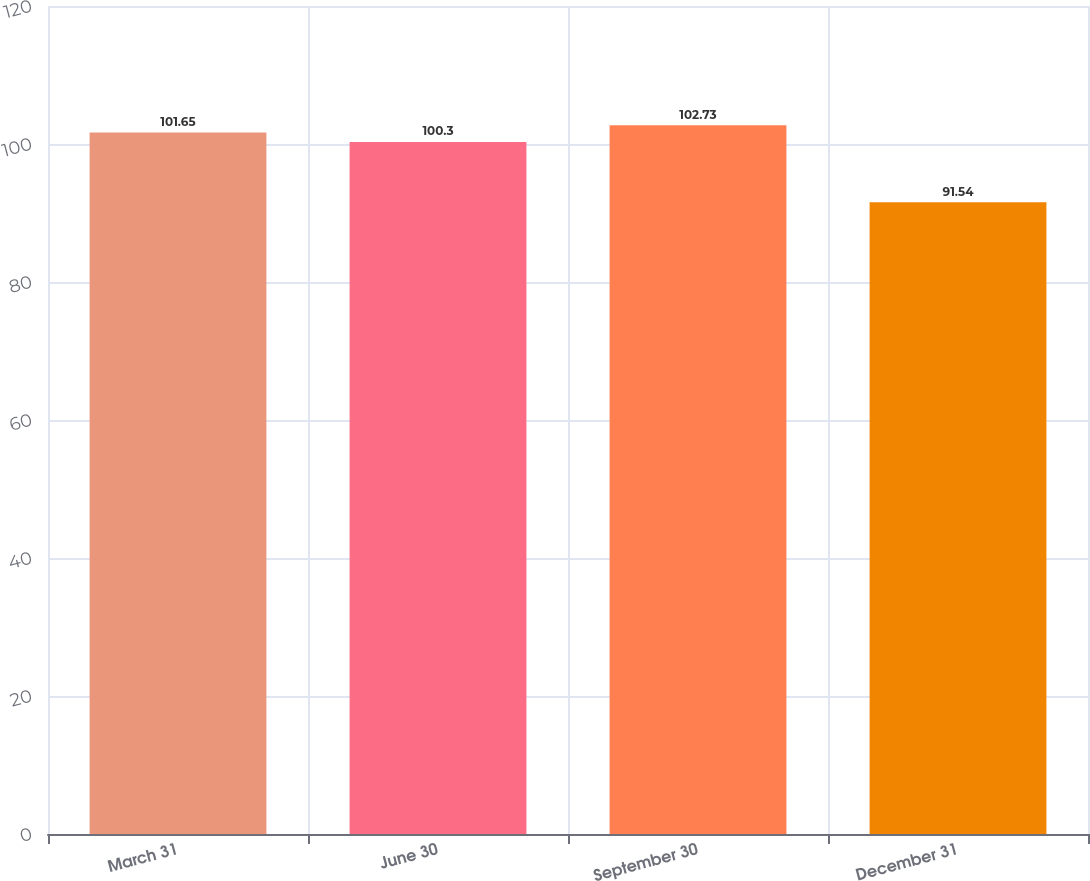<chart> <loc_0><loc_0><loc_500><loc_500><bar_chart><fcel>March 31<fcel>June 30<fcel>September 30<fcel>December 31<nl><fcel>101.65<fcel>100.3<fcel>102.73<fcel>91.54<nl></chart> 